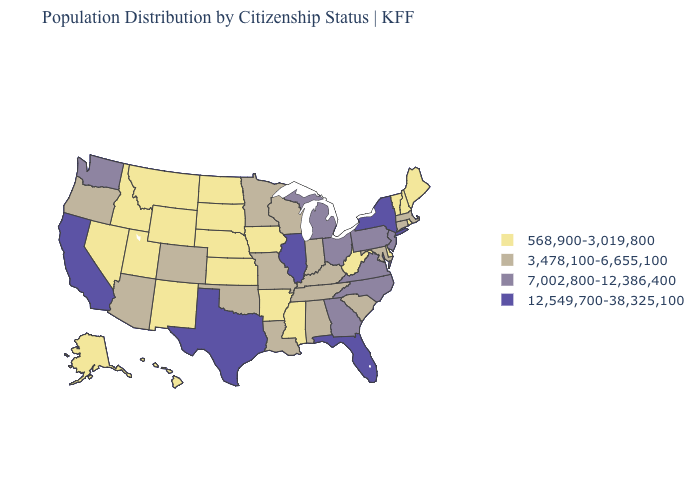What is the lowest value in the MidWest?
Write a very short answer. 568,900-3,019,800. What is the lowest value in states that border Ohio?
Answer briefly. 568,900-3,019,800. Which states have the highest value in the USA?
Answer briefly. California, Florida, Illinois, New York, Texas. Does Kansas have the same value as Rhode Island?
Short answer required. Yes. How many symbols are there in the legend?
Be succinct. 4. Name the states that have a value in the range 568,900-3,019,800?
Short answer required. Alaska, Arkansas, Delaware, Hawaii, Idaho, Iowa, Kansas, Maine, Mississippi, Montana, Nebraska, Nevada, New Hampshire, New Mexico, North Dakota, Rhode Island, South Dakota, Utah, Vermont, West Virginia, Wyoming. Which states have the lowest value in the USA?
Concise answer only. Alaska, Arkansas, Delaware, Hawaii, Idaho, Iowa, Kansas, Maine, Mississippi, Montana, Nebraska, Nevada, New Hampshire, New Mexico, North Dakota, Rhode Island, South Dakota, Utah, Vermont, West Virginia, Wyoming. Among the states that border Missouri , which have the highest value?
Write a very short answer. Illinois. Does Florida have the lowest value in the USA?
Short answer required. No. What is the lowest value in states that border Missouri?
Concise answer only. 568,900-3,019,800. Does Florida have the highest value in the USA?
Short answer required. Yes. Name the states that have a value in the range 7,002,800-12,386,400?
Give a very brief answer. Georgia, Michigan, New Jersey, North Carolina, Ohio, Pennsylvania, Virginia, Washington. Name the states that have a value in the range 3,478,100-6,655,100?
Short answer required. Alabama, Arizona, Colorado, Connecticut, Indiana, Kentucky, Louisiana, Maryland, Massachusetts, Minnesota, Missouri, Oklahoma, Oregon, South Carolina, Tennessee, Wisconsin. What is the value of Kansas?
Concise answer only. 568,900-3,019,800. Does Kansas have the lowest value in the USA?
Keep it brief. Yes. 